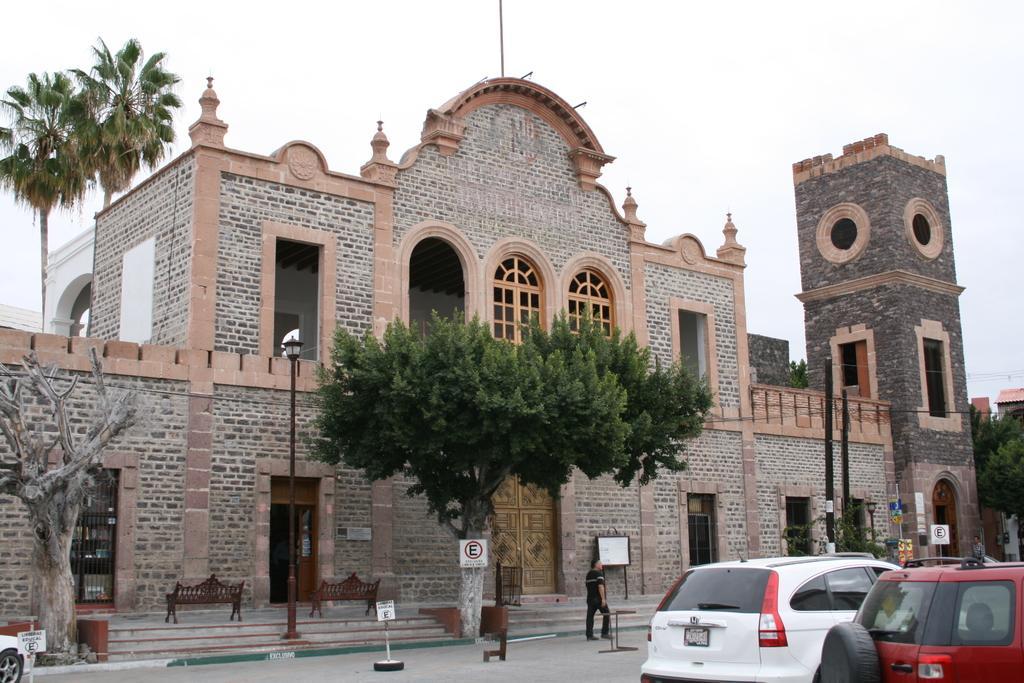Describe this image in one or two sentences. In the foreground of this picture, there are vehicles moving on the roads, poles trees and the sign boards. In the background, there is a building, benches, trees and the sky. 